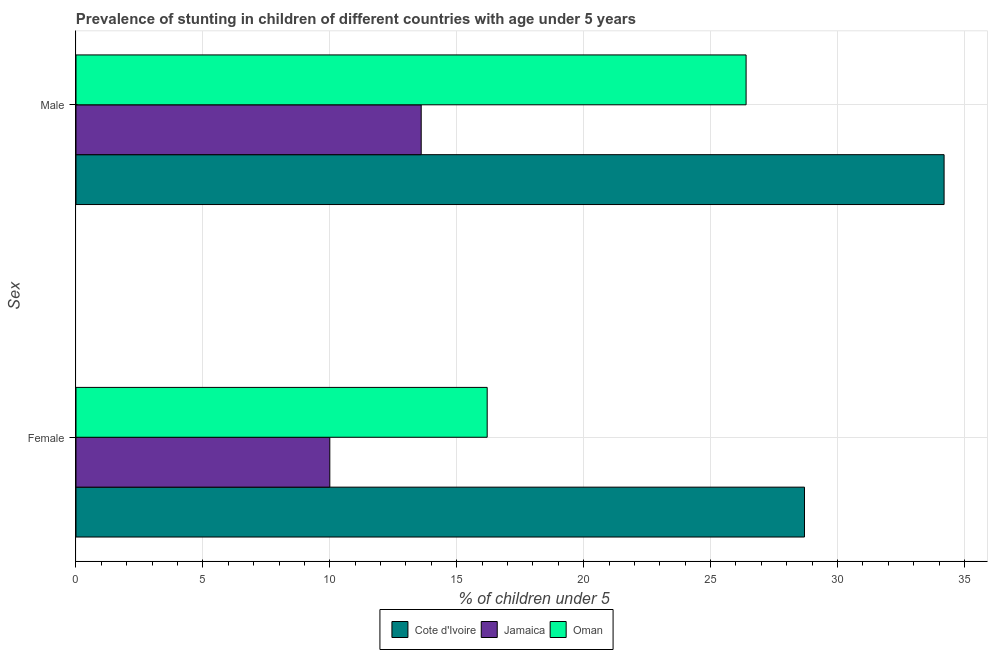How many different coloured bars are there?
Provide a short and direct response. 3. How many groups of bars are there?
Keep it short and to the point. 2. Are the number of bars on each tick of the Y-axis equal?
Keep it short and to the point. Yes. Across all countries, what is the maximum percentage of stunted female children?
Offer a very short reply. 28.7. Across all countries, what is the minimum percentage of stunted male children?
Offer a very short reply. 13.6. In which country was the percentage of stunted female children maximum?
Ensure brevity in your answer.  Cote d'Ivoire. In which country was the percentage of stunted female children minimum?
Provide a short and direct response. Jamaica. What is the total percentage of stunted male children in the graph?
Provide a short and direct response. 74.2. What is the difference between the percentage of stunted male children in Cote d'Ivoire and that in Oman?
Give a very brief answer. 7.8. What is the difference between the percentage of stunted female children in Oman and the percentage of stunted male children in Cote d'Ivoire?
Make the answer very short. -18. What is the average percentage of stunted female children per country?
Your answer should be compact. 18.3. What is the difference between the percentage of stunted male children and percentage of stunted female children in Jamaica?
Your answer should be very brief. 3.6. What is the ratio of the percentage of stunted male children in Jamaica to that in Cote d'Ivoire?
Ensure brevity in your answer.  0.4. In how many countries, is the percentage of stunted female children greater than the average percentage of stunted female children taken over all countries?
Your answer should be compact. 1. What does the 1st bar from the top in Male represents?
Your answer should be very brief. Oman. What does the 3rd bar from the bottom in Male represents?
Your answer should be very brief. Oman. How many bars are there?
Your response must be concise. 6. How many countries are there in the graph?
Give a very brief answer. 3. Are the values on the major ticks of X-axis written in scientific E-notation?
Your answer should be very brief. No. Does the graph contain any zero values?
Your answer should be compact. No. What is the title of the graph?
Keep it short and to the point. Prevalence of stunting in children of different countries with age under 5 years. Does "Costa Rica" appear as one of the legend labels in the graph?
Provide a short and direct response. No. What is the label or title of the X-axis?
Ensure brevity in your answer.   % of children under 5. What is the label or title of the Y-axis?
Make the answer very short. Sex. What is the  % of children under 5 in Cote d'Ivoire in Female?
Your answer should be very brief. 28.7. What is the  % of children under 5 of Jamaica in Female?
Give a very brief answer. 10. What is the  % of children under 5 of Oman in Female?
Your answer should be very brief. 16.2. What is the  % of children under 5 in Cote d'Ivoire in Male?
Offer a very short reply. 34.2. What is the  % of children under 5 in Jamaica in Male?
Offer a terse response. 13.6. What is the  % of children under 5 in Oman in Male?
Your response must be concise. 26.4. Across all Sex, what is the maximum  % of children under 5 in Cote d'Ivoire?
Offer a very short reply. 34.2. Across all Sex, what is the maximum  % of children under 5 in Jamaica?
Ensure brevity in your answer.  13.6. Across all Sex, what is the maximum  % of children under 5 in Oman?
Your response must be concise. 26.4. Across all Sex, what is the minimum  % of children under 5 of Cote d'Ivoire?
Your response must be concise. 28.7. Across all Sex, what is the minimum  % of children under 5 in Jamaica?
Provide a short and direct response. 10. Across all Sex, what is the minimum  % of children under 5 of Oman?
Your answer should be very brief. 16.2. What is the total  % of children under 5 of Cote d'Ivoire in the graph?
Offer a terse response. 62.9. What is the total  % of children under 5 of Jamaica in the graph?
Ensure brevity in your answer.  23.6. What is the total  % of children under 5 in Oman in the graph?
Your answer should be very brief. 42.6. What is the difference between the  % of children under 5 of Cote d'Ivoire in Female and the  % of children under 5 of Jamaica in Male?
Your answer should be very brief. 15.1. What is the difference between the  % of children under 5 of Jamaica in Female and the  % of children under 5 of Oman in Male?
Make the answer very short. -16.4. What is the average  % of children under 5 of Cote d'Ivoire per Sex?
Your answer should be compact. 31.45. What is the average  % of children under 5 of Jamaica per Sex?
Make the answer very short. 11.8. What is the average  % of children under 5 in Oman per Sex?
Offer a very short reply. 21.3. What is the difference between the  % of children under 5 of Jamaica and  % of children under 5 of Oman in Female?
Your response must be concise. -6.2. What is the difference between the  % of children under 5 of Cote d'Ivoire and  % of children under 5 of Jamaica in Male?
Offer a very short reply. 20.6. What is the difference between the  % of children under 5 in Cote d'Ivoire and  % of children under 5 in Oman in Male?
Your answer should be compact. 7.8. What is the ratio of the  % of children under 5 in Cote d'Ivoire in Female to that in Male?
Provide a short and direct response. 0.84. What is the ratio of the  % of children under 5 of Jamaica in Female to that in Male?
Keep it short and to the point. 0.74. What is the ratio of the  % of children under 5 in Oman in Female to that in Male?
Provide a succinct answer. 0.61. What is the difference between the highest and the second highest  % of children under 5 of Jamaica?
Keep it short and to the point. 3.6. What is the difference between the highest and the second highest  % of children under 5 in Oman?
Make the answer very short. 10.2. What is the difference between the highest and the lowest  % of children under 5 of Cote d'Ivoire?
Keep it short and to the point. 5.5. What is the difference between the highest and the lowest  % of children under 5 in Oman?
Provide a short and direct response. 10.2. 